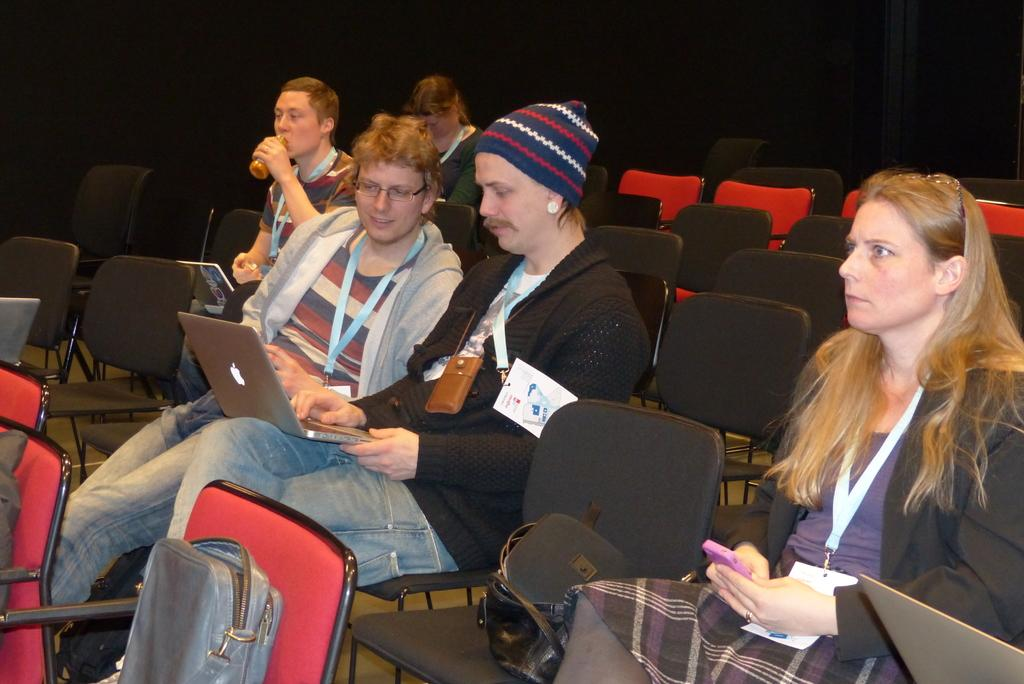How many people are present in the image? There are five persons sitting in the image. What are the persons sitting on? There are chairs in the image. What items can be seen with the persons? There are bags and laptops in the image. What is the color of the background in the image? The background of the image is dark. How many fish can be seen swimming in the image? There are no fish present in the image. What is the fifth person in the image thinking about? The provided facts do not give any information about the thoughts or feelings of the persons in the image. 